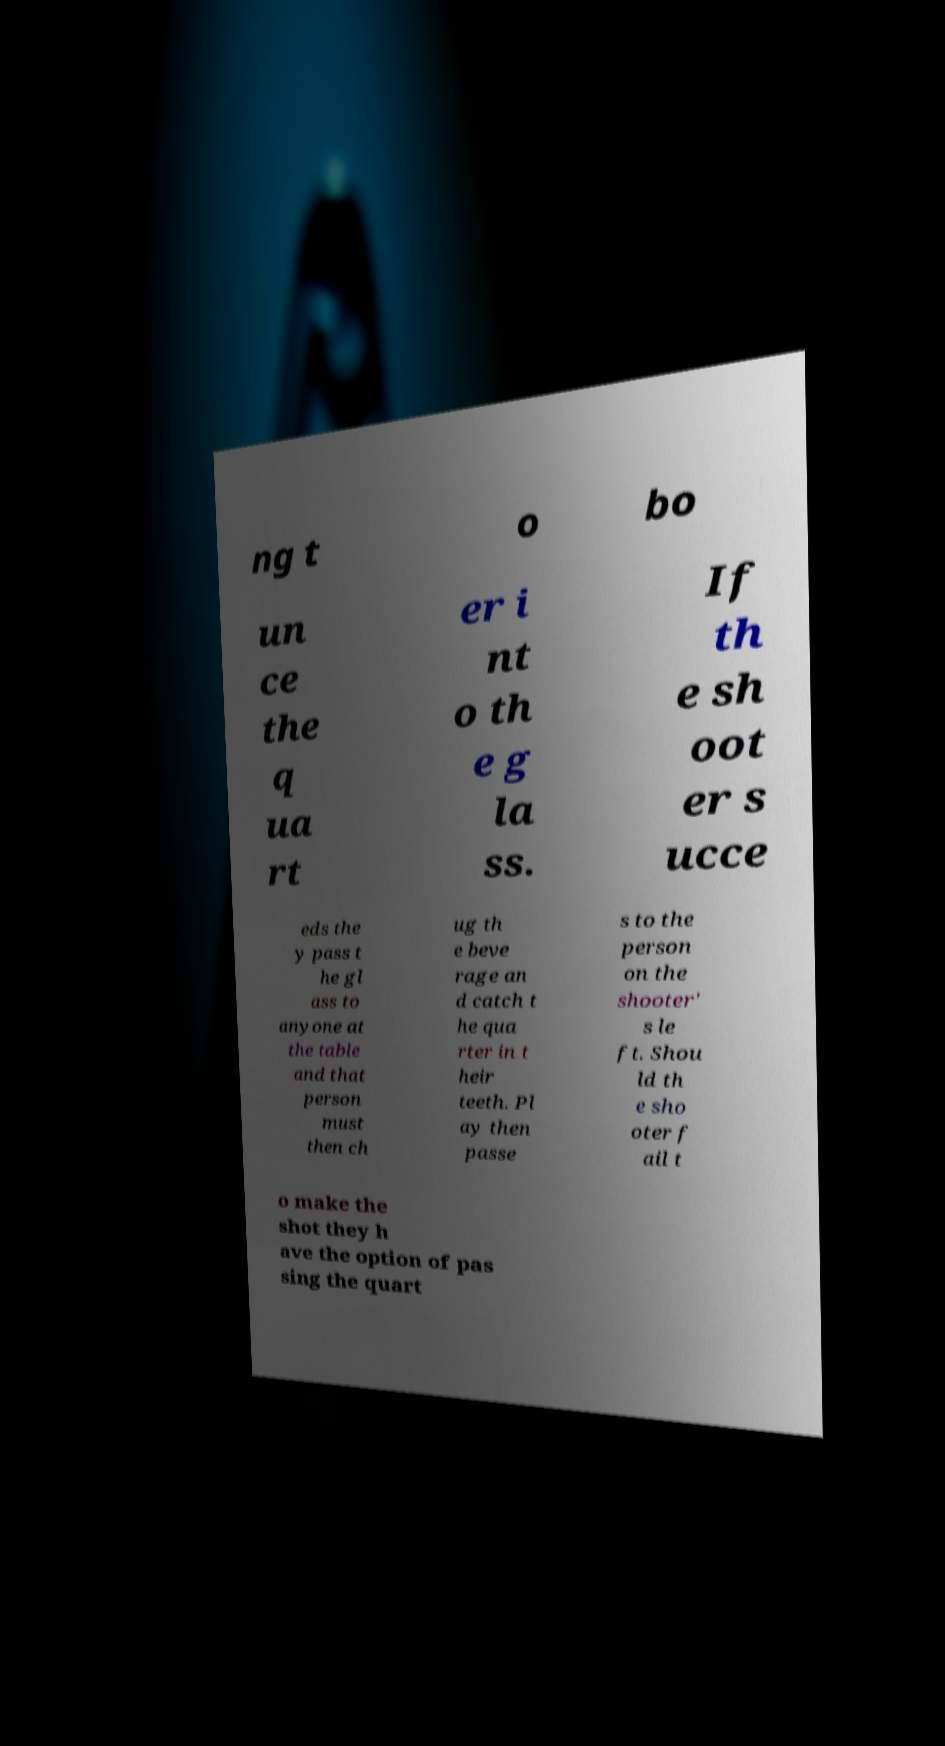Could you assist in decoding the text presented in this image and type it out clearly? ng t o bo un ce the q ua rt er i nt o th e g la ss. If th e sh oot er s ucce eds the y pass t he gl ass to anyone at the table and that person must then ch ug th e beve rage an d catch t he qua rter in t heir teeth. Pl ay then passe s to the person on the shooter' s le ft. Shou ld th e sho oter f ail t o make the shot they h ave the option of pas sing the quart 